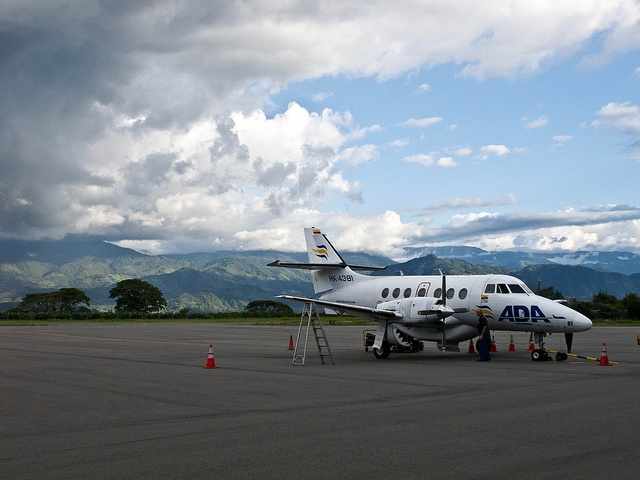Describe the objects in this image and their specific colors. I can see airplane in gray, black, darkgray, and lightgray tones and people in gray, black, and maroon tones in this image. 